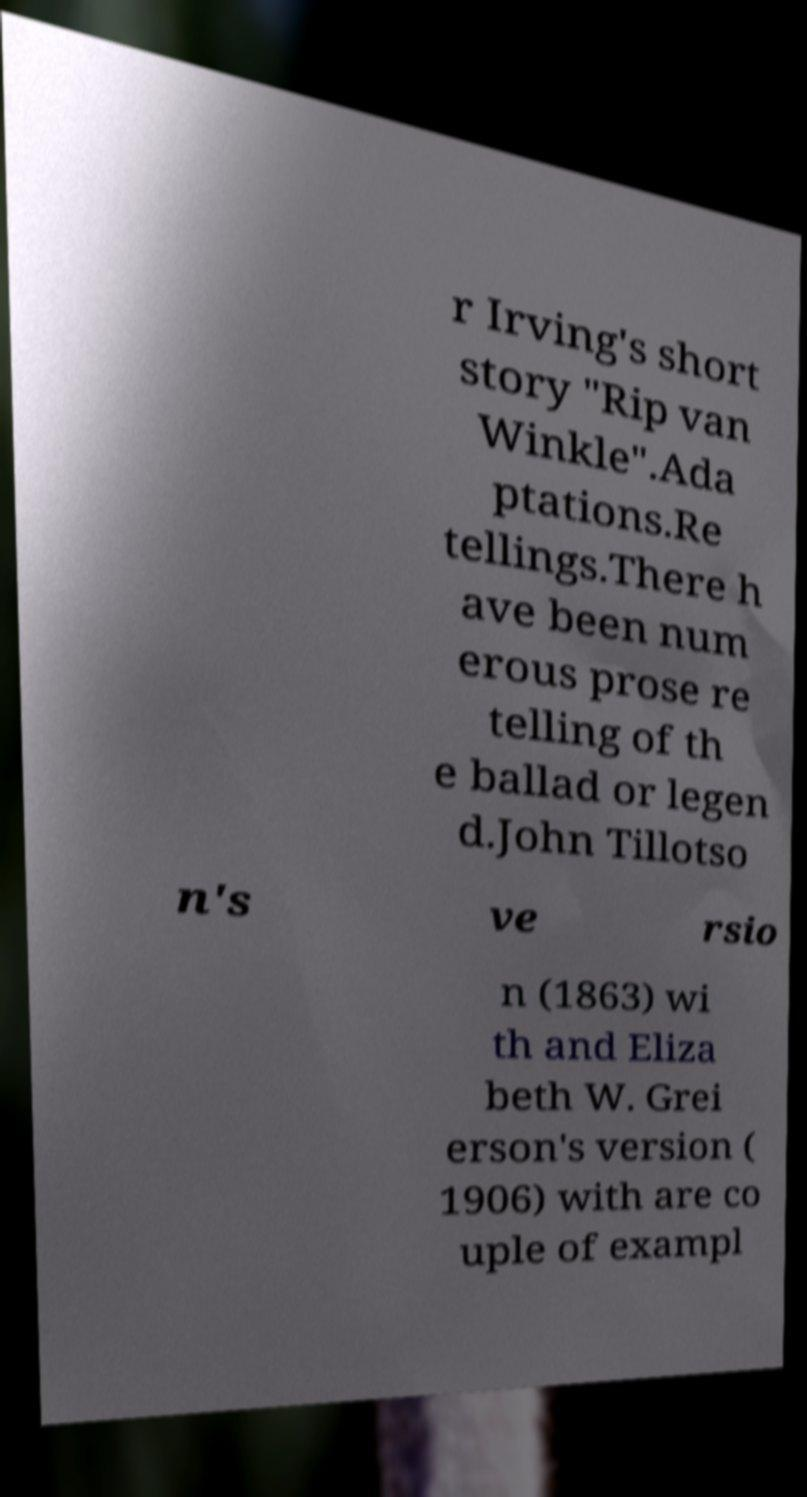Can you accurately transcribe the text from the provided image for me? r Irving's short story "Rip van Winkle".Ada ptations.Re tellings.There h ave been num erous prose re telling of th e ballad or legen d.John Tillotso n's ve rsio n (1863) wi th and Eliza beth W. Grei erson's version ( 1906) with are co uple of exampl 